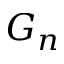<formula> <loc_0><loc_0><loc_500><loc_500>G _ { n }</formula> 